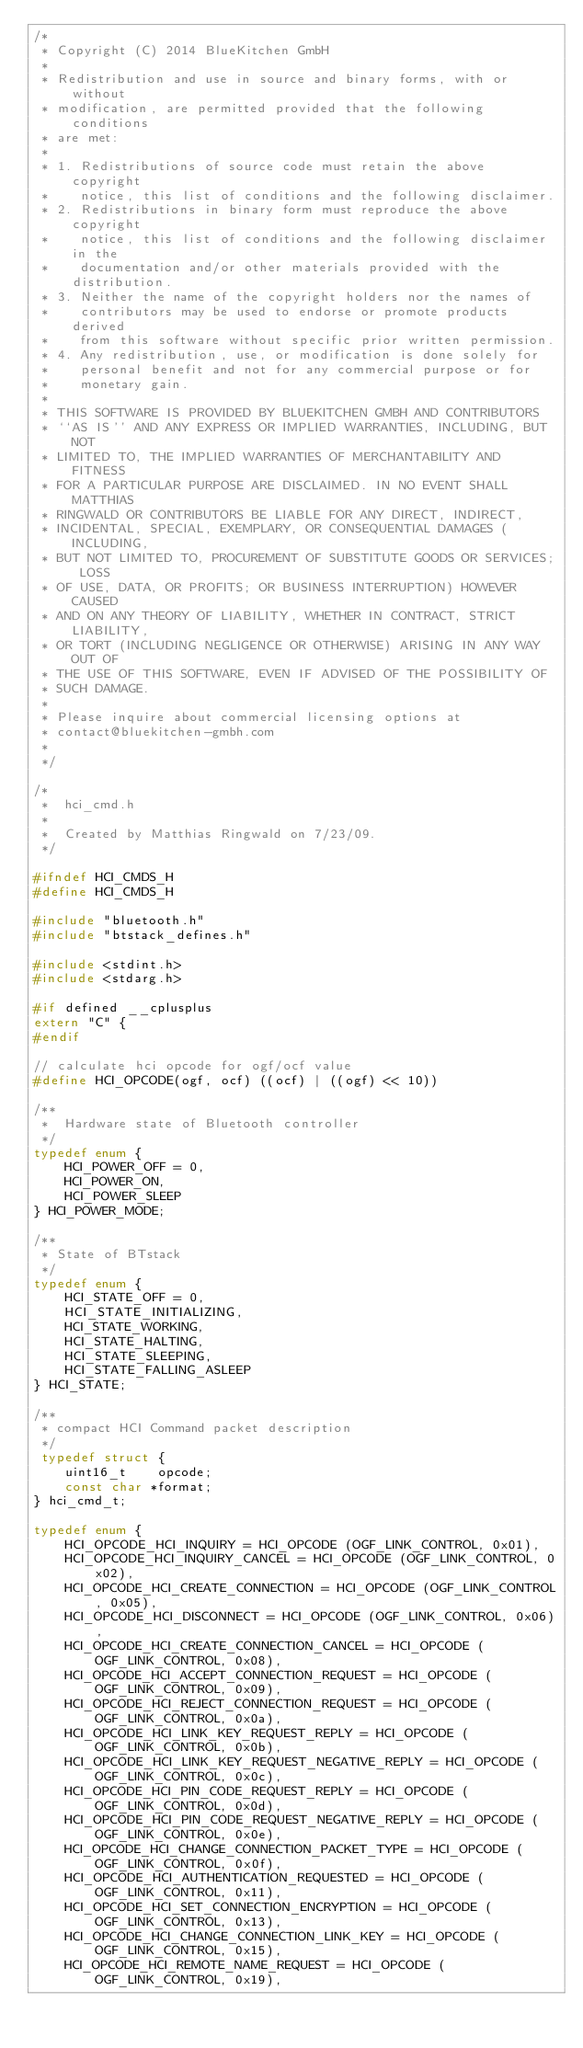Convert code to text. <code><loc_0><loc_0><loc_500><loc_500><_C_>/*
 * Copyright (C) 2014 BlueKitchen GmbH
 *
 * Redistribution and use in source and binary forms, with or without
 * modification, are permitted provided that the following conditions
 * are met:
 *
 * 1. Redistributions of source code must retain the above copyright
 *    notice, this list of conditions and the following disclaimer.
 * 2. Redistributions in binary form must reproduce the above copyright
 *    notice, this list of conditions and the following disclaimer in the
 *    documentation and/or other materials provided with the distribution.
 * 3. Neither the name of the copyright holders nor the names of
 *    contributors may be used to endorse or promote products derived
 *    from this software without specific prior written permission.
 * 4. Any redistribution, use, or modification is done solely for
 *    personal benefit and not for any commercial purpose or for
 *    monetary gain.
 *
 * THIS SOFTWARE IS PROVIDED BY BLUEKITCHEN GMBH AND CONTRIBUTORS
 * ``AS IS'' AND ANY EXPRESS OR IMPLIED WARRANTIES, INCLUDING, BUT NOT
 * LIMITED TO, THE IMPLIED WARRANTIES OF MERCHANTABILITY AND FITNESS
 * FOR A PARTICULAR PURPOSE ARE DISCLAIMED. IN NO EVENT SHALL MATTHIAS
 * RINGWALD OR CONTRIBUTORS BE LIABLE FOR ANY DIRECT, INDIRECT,
 * INCIDENTAL, SPECIAL, EXEMPLARY, OR CONSEQUENTIAL DAMAGES (INCLUDING,
 * BUT NOT LIMITED TO, PROCUREMENT OF SUBSTITUTE GOODS OR SERVICES; LOSS
 * OF USE, DATA, OR PROFITS; OR BUSINESS INTERRUPTION) HOWEVER CAUSED
 * AND ON ANY THEORY OF LIABILITY, WHETHER IN CONTRACT, STRICT LIABILITY,
 * OR TORT (INCLUDING NEGLIGENCE OR OTHERWISE) ARISING IN ANY WAY OUT OF
 * THE USE OF THIS SOFTWARE, EVEN IF ADVISED OF THE POSSIBILITY OF
 * SUCH DAMAGE.
 *
 * Please inquire about commercial licensing options at 
 * contact@bluekitchen-gmbh.com
 *
 */

/*
 *  hci_cmd.h
 *
 *  Created by Matthias Ringwald on 7/23/09.
 */

#ifndef HCI_CMDS_H
#define HCI_CMDS_H

#include "bluetooth.h"
#include "btstack_defines.h"

#include <stdint.h>
#include <stdarg.h>

#if defined __cplusplus
extern "C" {
#endif

// calculate hci opcode for ogf/ocf value
#define HCI_OPCODE(ogf, ocf) ((ocf) | ((ogf) << 10))

/**
 *  Hardware state of Bluetooth controller 
 */
typedef enum {
    HCI_POWER_OFF = 0,
    HCI_POWER_ON,
    HCI_POWER_SLEEP
} HCI_POWER_MODE;

/**
 * State of BTstack 
 */
typedef enum {
    HCI_STATE_OFF = 0,
    HCI_STATE_INITIALIZING,
    HCI_STATE_WORKING,
    HCI_STATE_HALTING,
    HCI_STATE_SLEEPING,
    HCI_STATE_FALLING_ASLEEP
} HCI_STATE;

/** 
 * compact HCI Command packet description
 */
 typedef struct {
    uint16_t    opcode;
    const char *format;
} hci_cmd_t;

typedef enum {
    HCI_OPCODE_HCI_INQUIRY = HCI_OPCODE (OGF_LINK_CONTROL, 0x01),
    HCI_OPCODE_HCI_INQUIRY_CANCEL = HCI_OPCODE (OGF_LINK_CONTROL, 0x02),
    HCI_OPCODE_HCI_CREATE_CONNECTION = HCI_OPCODE (OGF_LINK_CONTROL, 0x05),
    HCI_OPCODE_HCI_DISCONNECT = HCI_OPCODE (OGF_LINK_CONTROL, 0x06),
    HCI_OPCODE_HCI_CREATE_CONNECTION_CANCEL = HCI_OPCODE (OGF_LINK_CONTROL, 0x08),
    HCI_OPCODE_HCI_ACCEPT_CONNECTION_REQUEST = HCI_OPCODE (OGF_LINK_CONTROL, 0x09),
    HCI_OPCODE_HCI_REJECT_CONNECTION_REQUEST = HCI_OPCODE (OGF_LINK_CONTROL, 0x0a),
    HCI_OPCODE_HCI_LINK_KEY_REQUEST_REPLY = HCI_OPCODE (OGF_LINK_CONTROL, 0x0b),
    HCI_OPCODE_HCI_LINK_KEY_REQUEST_NEGATIVE_REPLY = HCI_OPCODE (OGF_LINK_CONTROL, 0x0c),
    HCI_OPCODE_HCI_PIN_CODE_REQUEST_REPLY = HCI_OPCODE (OGF_LINK_CONTROL, 0x0d),
    HCI_OPCODE_HCI_PIN_CODE_REQUEST_NEGATIVE_REPLY = HCI_OPCODE (OGF_LINK_CONTROL, 0x0e),
    HCI_OPCODE_HCI_CHANGE_CONNECTION_PACKET_TYPE = HCI_OPCODE (OGF_LINK_CONTROL, 0x0f),
    HCI_OPCODE_HCI_AUTHENTICATION_REQUESTED = HCI_OPCODE (OGF_LINK_CONTROL, 0x11),
    HCI_OPCODE_HCI_SET_CONNECTION_ENCRYPTION = HCI_OPCODE (OGF_LINK_CONTROL, 0x13),
    HCI_OPCODE_HCI_CHANGE_CONNECTION_LINK_KEY = HCI_OPCODE (OGF_LINK_CONTROL, 0x15),
    HCI_OPCODE_HCI_REMOTE_NAME_REQUEST = HCI_OPCODE (OGF_LINK_CONTROL, 0x19),</code> 